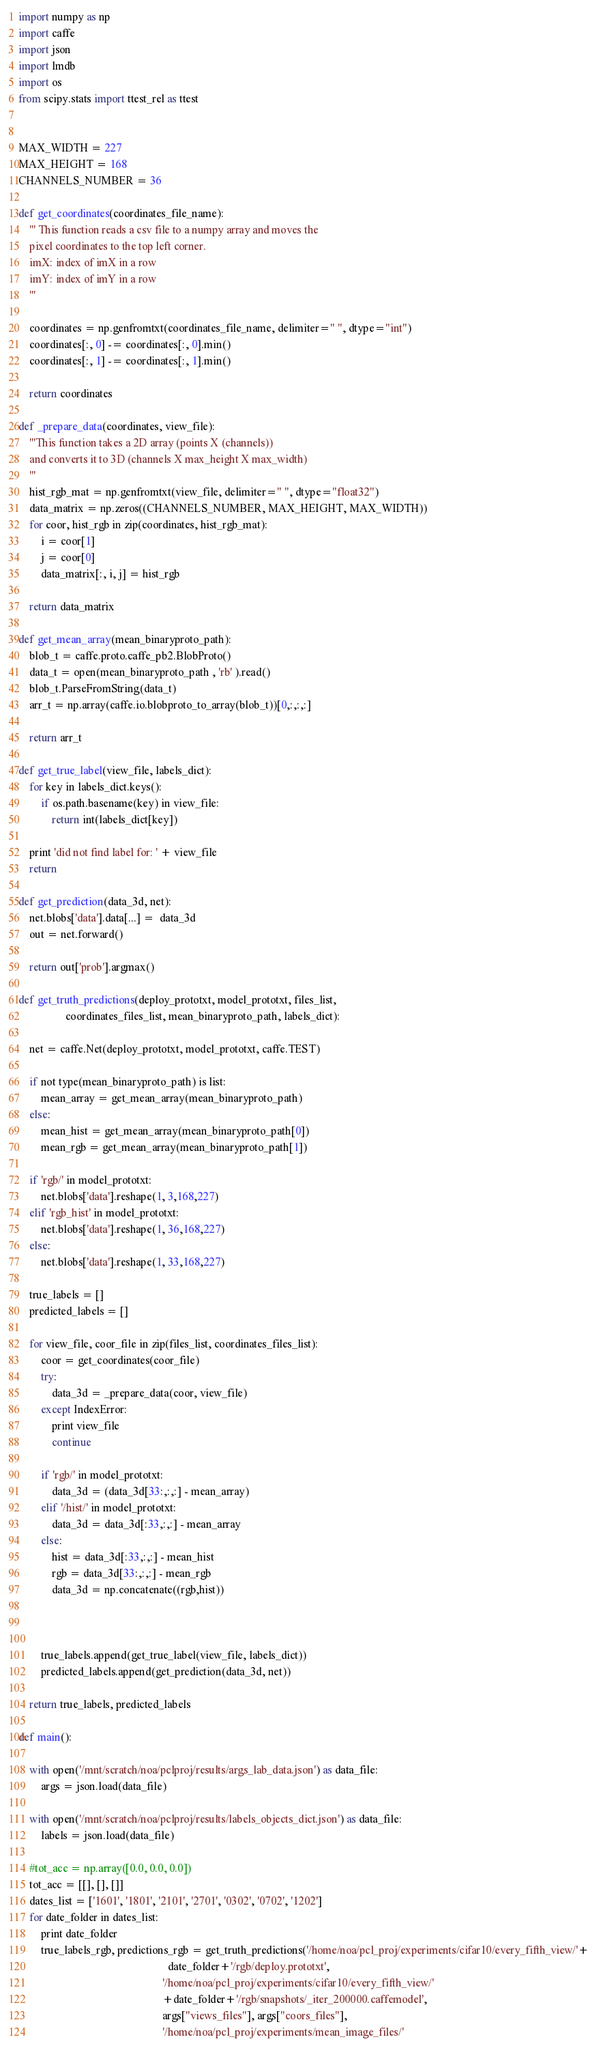<code> <loc_0><loc_0><loc_500><loc_500><_Python_>import numpy as np
import caffe
import json
import lmdb
import os
from scipy.stats import ttest_rel as ttest


MAX_WIDTH = 227
MAX_HEIGHT = 168
CHANNELS_NUMBER = 36

def get_coordinates(coordinates_file_name):
	''' This function reads a csv file to a numpy array and moves the 
	pixel coordinates to the top left corner.
	imX: index of imX in a row
	imY: index of imY in a row
	'''

	coordinates = np.genfromtxt(coordinates_file_name, delimiter=" ", dtype="int")
	coordinates[:, 0] -= coordinates[:, 0].min()
	coordinates[:, 1] -= coordinates[:, 1].min()
	
	return coordinates

def _prepare_data(coordinates, view_file):
	'''This function takes a 2D array (points X (channels)) 
	and converts it to 3D (channels X max_height X max_width)
	'''
	hist_rgb_mat = np.genfromtxt(view_file, delimiter=" ", dtype="float32")
	data_matrix = np.zeros((CHANNELS_NUMBER, MAX_HEIGHT, MAX_WIDTH))
	for coor, hist_rgb in zip(coordinates, hist_rgb_mat):
		i = coor[1]
		j = coor[0]
		data_matrix[:, i, j] = hist_rgb

	return data_matrix

def get_mean_array(mean_binaryproto_path):
	blob_t = caffe.proto.caffe_pb2.BlobProto()
	data_t = open(mean_binaryproto_path , 'rb' ).read()
	blob_t.ParseFromString(data_t)
	arr_t = np.array(caffe.io.blobproto_to_array(blob_t))[0,:,:,:]
	
	return arr_t

def get_true_label(view_file, labels_dict):
	for key in labels_dict.keys():
		if os.path.basename(key) in view_file:
			return int(labels_dict[key])
	
	print 'did not find label for: ' + view_file
	return

def get_prediction(data_3d, net):
	net.blobs['data'].data[...] =  data_3d
	out = net.forward()
	
	return out['prob'].argmax()

def get_truth_predictions(deploy_prototxt, model_prototxt, files_list, 
				 coordinates_files_list, mean_binaryproto_path, labels_dict):
	
	net = caffe.Net(deploy_prototxt, model_prototxt, caffe.TEST)
	
	if not type(mean_binaryproto_path) is list:
		mean_array = get_mean_array(mean_binaryproto_path)
	else:
		mean_hist = get_mean_array(mean_binaryproto_path[0])
		mean_rgb = get_mean_array(mean_binaryproto_path[1])
	
	if 'rgb/' in model_prototxt:
		net.blobs['data'].reshape(1, 3,168,227)
	elif 'rgb_hist' in model_prototxt:
		net.blobs['data'].reshape(1, 36,168,227)
	else:
		net.blobs['data'].reshape(1, 33,168,227)
	
	true_labels = []
	predicted_labels = []
	
	for view_file, coor_file in zip(files_list, coordinates_files_list):
		coor = get_coordinates(coor_file)
		try:
			data_3d = _prepare_data(coor, view_file)
		except IndexError:
			print view_file
			continue
		
		if 'rgb/' in model_prototxt:
			data_3d = (data_3d[33:,:,:] - mean_array)
		elif '/hist/' in model_prototxt:
			data_3d = data_3d[:33,:,:] - mean_array
		else:
			hist = data_3d[:33,:,:] - mean_hist
			rgb = data_3d[33:,:,:] - mean_rgb
			data_3d = np.concatenate((rgb,hist))
			
		
		
		true_labels.append(get_true_label(view_file, labels_dict))
		predicted_labels.append(get_prediction(data_3d, net))
	
	return true_labels, predicted_labels

def main():

	with open('/mnt/scratch/noa/pclproj/results/args_lab_data.json') as data_file:
		args = json.load(data_file)

	with open('/mnt/scratch/noa/pclproj/results/labels_objects_dict.json') as data_file:
		labels = json.load(data_file)

	#tot_acc = np.array([0.0, 0.0, 0.0])
	tot_acc = [[], [], []]
	dates_list = ['1601', '1801', '2101', '2701', '0302', '0702', '1202']
	for date_folder in dates_list:
		print date_folder
		true_labels_rgb, predictions_rgb = get_truth_predictions('/home/noa/pcl_proj/experiments/cifar10/every_fifth_view/'+
													  date_folder+'/rgb/deploy.prototxt',
													'/home/noa/pcl_proj/experiments/cifar10/every_fifth_view/' 
													+date_folder+'/rgb/snapshots/_iter_200000.caffemodel',
													args["views_files"], args["coors_files"], 
													'/home/noa/pcl_proj/experiments/mean_image_files/'</code> 